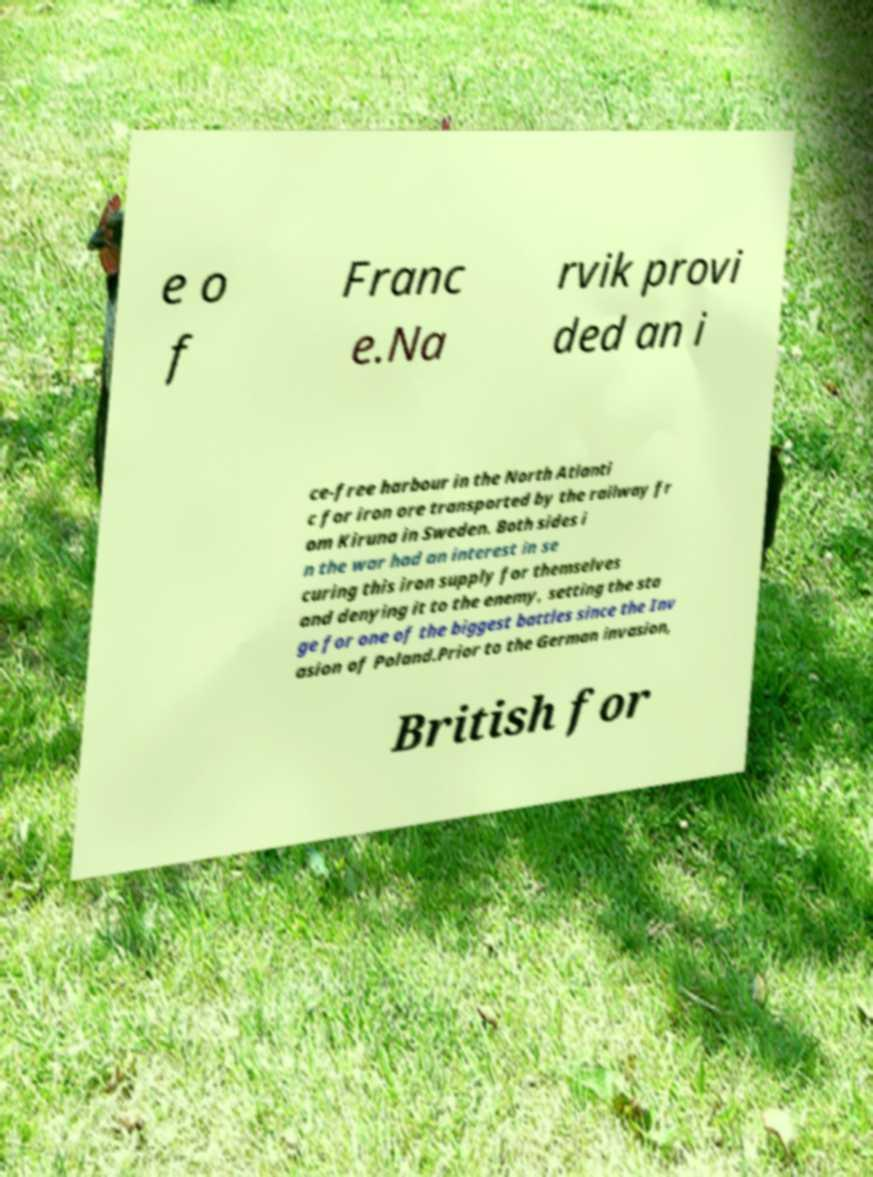There's text embedded in this image that I need extracted. Can you transcribe it verbatim? e o f Franc e.Na rvik provi ded an i ce-free harbour in the North Atlanti c for iron ore transported by the railway fr om Kiruna in Sweden. Both sides i n the war had an interest in se curing this iron supply for themselves and denying it to the enemy, setting the sta ge for one of the biggest battles since the Inv asion of Poland.Prior to the German invasion, British for 